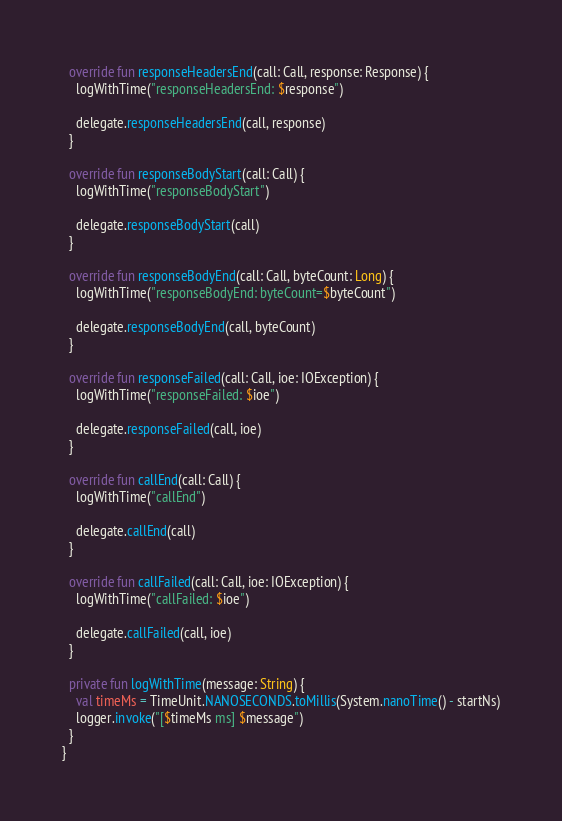<code> <loc_0><loc_0><loc_500><loc_500><_Kotlin_>  override fun responseHeadersEnd(call: Call, response: Response) {
    logWithTime("responseHeadersEnd: $response")

    delegate.responseHeadersEnd(call, response)
  }

  override fun responseBodyStart(call: Call) {
    logWithTime("responseBodyStart")

    delegate.responseBodyStart(call)
  }

  override fun responseBodyEnd(call: Call, byteCount: Long) {
    logWithTime("responseBodyEnd: byteCount=$byteCount")

    delegate.responseBodyEnd(call, byteCount)
  }

  override fun responseFailed(call: Call, ioe: IOException) {
    logWithTime("responseFailed: $ioe")

    delegate.responseFailed(call, ioe)
  }

  override fun callEnd(call: Call) {
    logWithTime("callEnd")

    delegate.callEnd(call)
  }

  override fun callFailed(call: Call, ioe: IOException) {
    logWithTime("callFailed: $ioe")

    delegate.callFailed(call, ioe)
  }

  private fun logWithTime(message: String) {
    val timeMs = TimeUnit.NANOSECONDS.toMillis(System.nanoTime() - startNs)
    logger.invoke("[$timeMs ms] $message")
  }
}
</code> 